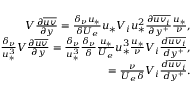<formula> <loc_0><loc_0><loc_500><loc_500>\begin{array} { r } { V \frac { \partial \overline { u v } } { \partial y } = \frac { \delta _ { \nu } u _ { * } } { \delta U _ { e } } u _ { * } V _ { i } u _ { * } ^ { 2 } \frac { \partial \overline { { u v _ { i } } } } { \partial y ^ { + } } \frac { u _ { * } } { \nu } , } \\ { \frac { \delta _ { \nu } } { u _ { * } ^ { 3 } } V \frac { \partial \overline { u v } } { \partial y } = \frac { \delta _ { \nu } } { u _ { * } ^ { 3 } } \frac { \delta _ { \nu } } { \delta } \frac { u _ { * } } { U _ { e } } u _ { * } ^ { 3 } \frac { u _ { * } } { \nu } V _ { i } \frac { d \overline { { u v _ { i } } } } { d y ^ { + } } , } \\ { = \frac { \nu } { U _ { e } \delta } V _ { i } \frac { d \overline { { u v _ { i } } } } { d y ^ { + } } . } \end{array}</formula> 